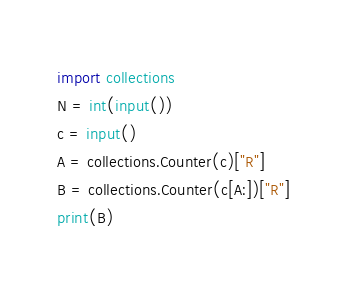<code> <loc_0><loc_0><loc_500><loc_500><_Python_>import collections
N = int(input())
c = input()
A = collections.Counter(c)["R"]
B = collections.Counter(c[A:])["R"]
print(B)</code> 